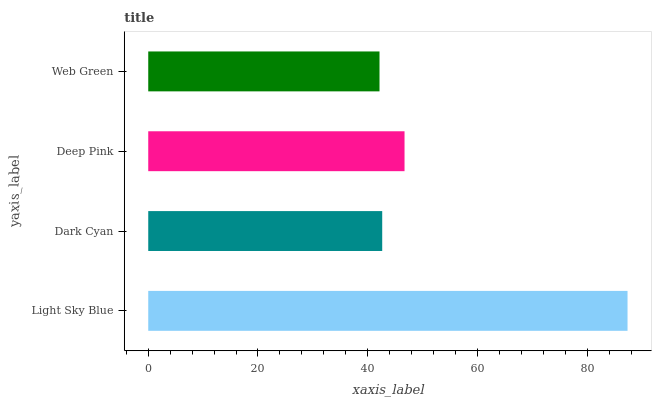Is Web Green the minimum?
Answer yes or no. Yes. Is Light Sky Blue the maximum?
Answer yes or no. Yes. Is Dark Cyan the minimum?
Answer yes or no. No. Is Dark Cyan the maximum?
Answer yes or no. No. Is Light Sky Blue greater than Dark Cyan?
Answer yes or no. Yes. Is Dark Cyan less than Light Sky Blue?
Answer yes or no. Yes. Is Dark Cyan greater than Light Sky Blue?
Answer yes or no. No. Is Light Sky Blue less than Dark Cyan?
Answer yes or no. No. Is Deep Pink the high median?
Answer yes or no. Yes. Is Dark Cyan the low median?
Answer yes or no. Yes. Is Dark Cyan the high median?
Answer yes or no. No. Is Light Sky Blue the low median?
Answer yes or no. No. 